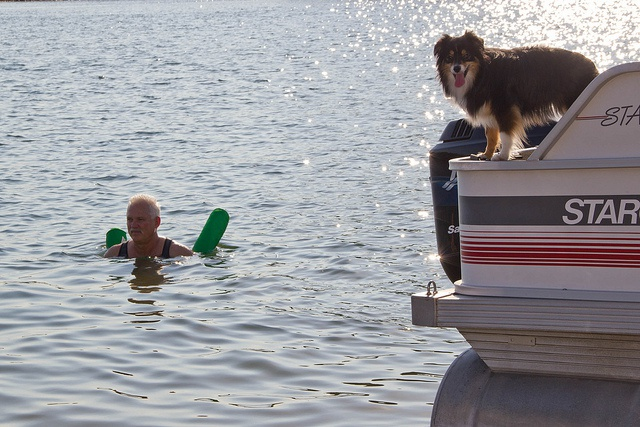Describe the objects in this image and their specific colors. I can see boat in black and gray tones, dog in black and gray tones, people in black, maroon, gray, and lightgray tones, and skis in black, darkgreen, and teal tones in this image. 